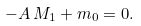<formula> <loc_0><loc_0><loc_500><loc_500>- A \, M _ { 1 } + m _ { 0 } = 0 .</formula> 